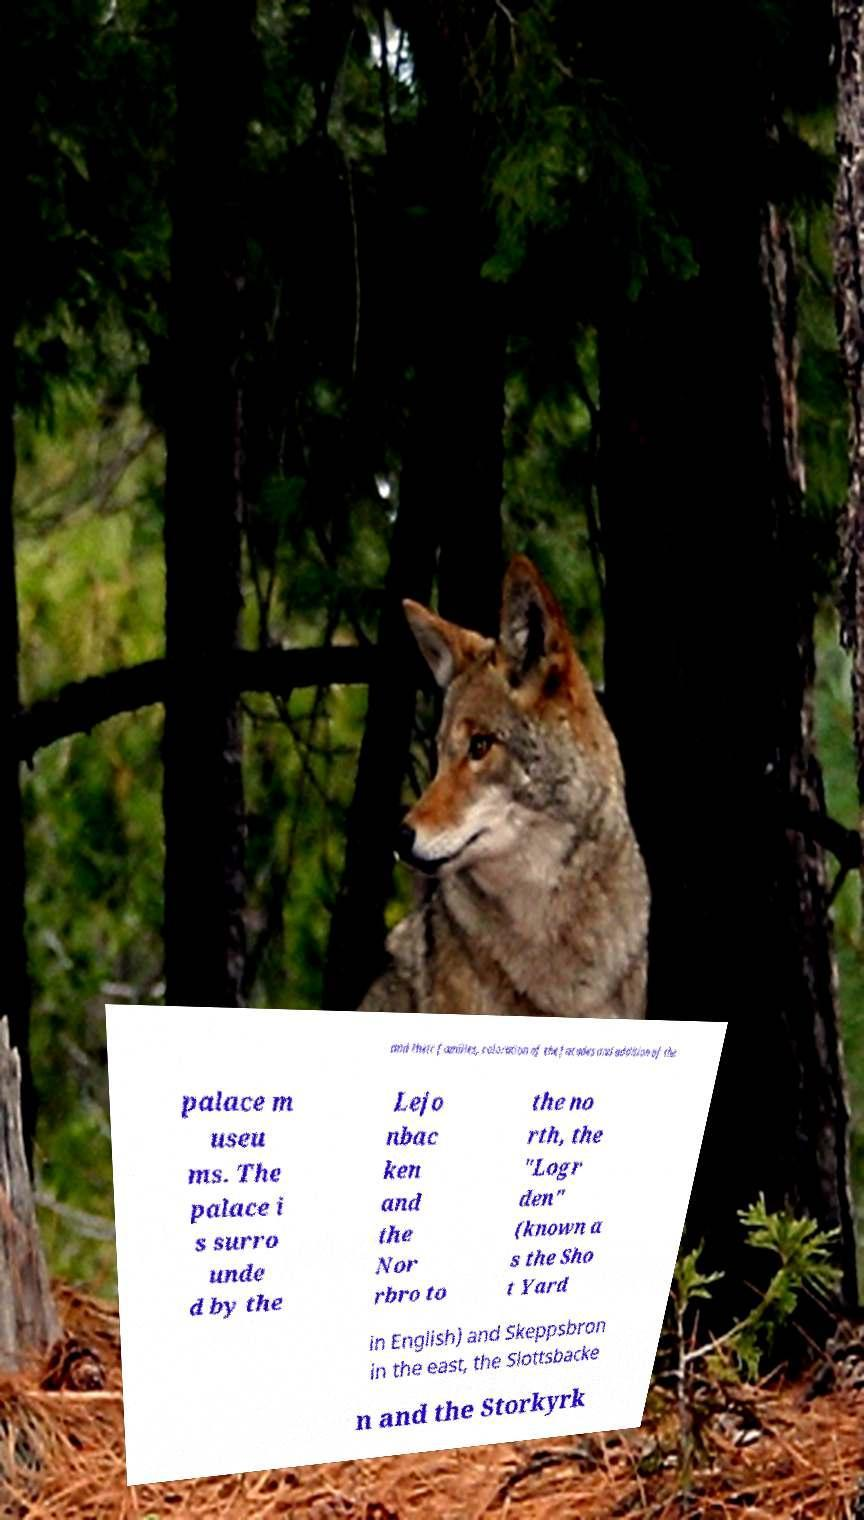Can you accurately transcribe the text from the provided image for me? and their families, coloration of the facades and addition of the palace m useu ms. The palace i s surro unde d by the Lejo nbac ken and the Nor rbro to the no rth, the "Logr den" (known a s the Sho t Yard in English) and Skeppsbron in the east, the Slottsbacke n and the Storkyrk 